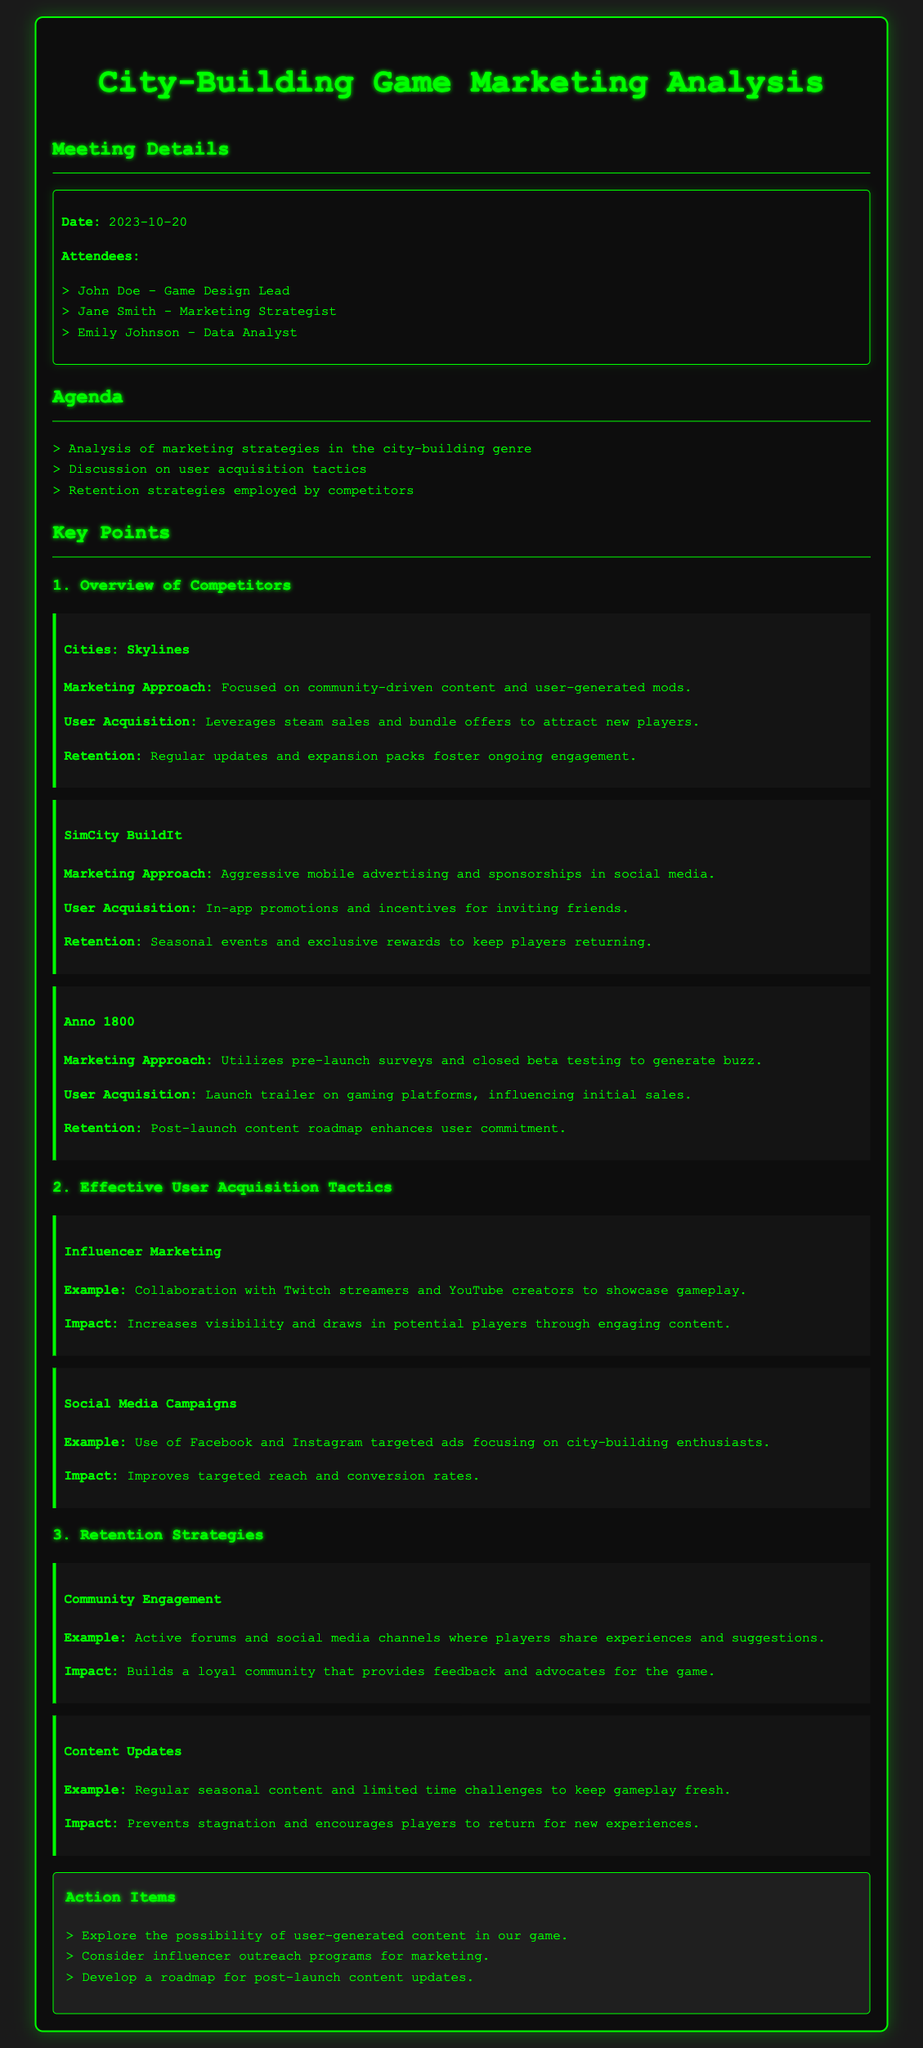what is the date of the meeting? The meeting date is mentioned clearly at the beginning of the document.
Answer: 2023-10-20 who is the Game Design Lead? The document lists the attendees and their roles, specifically noting the Game Design Lead.
Answer: John Doe what marketing approach does Cities: Skylines use? The marketing approach for Cities: Skylines is described in the key points section of the document.
Answer: Community-driven content and user-generated mods what user acquisition tactic does SimCity BuildIt employ? A specific user acquisition tactic for SimCity BuildIt is outlined in its corresponding key point.
Answer: In-app promotions and incentives for inviting friends how does Anno 1800 enhance user commitment? The retention strategy of Anno 1800 is mentioned, which highlights how they keep players engaged post-launch.
Answer: Post-launch content roadmap what is one example of effective user acquisition tactics? The document contains examples of effective user acquisition tactics under a specific section.
Answer: Influencer Marketing what is the impact of community engagement? The document explains the impact of community engagement in the retention strategies section.
Answer: Builds a loyal community how many action items are listed? The number of action items can be counted in the action items section of the document.
Answer: Three 